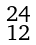<formula> <loc_0><loc_0><loc_500><loc_500>\begin{smallmatrix} 2 4 \\ 1 2 \end{smallmatrix}</formula> 